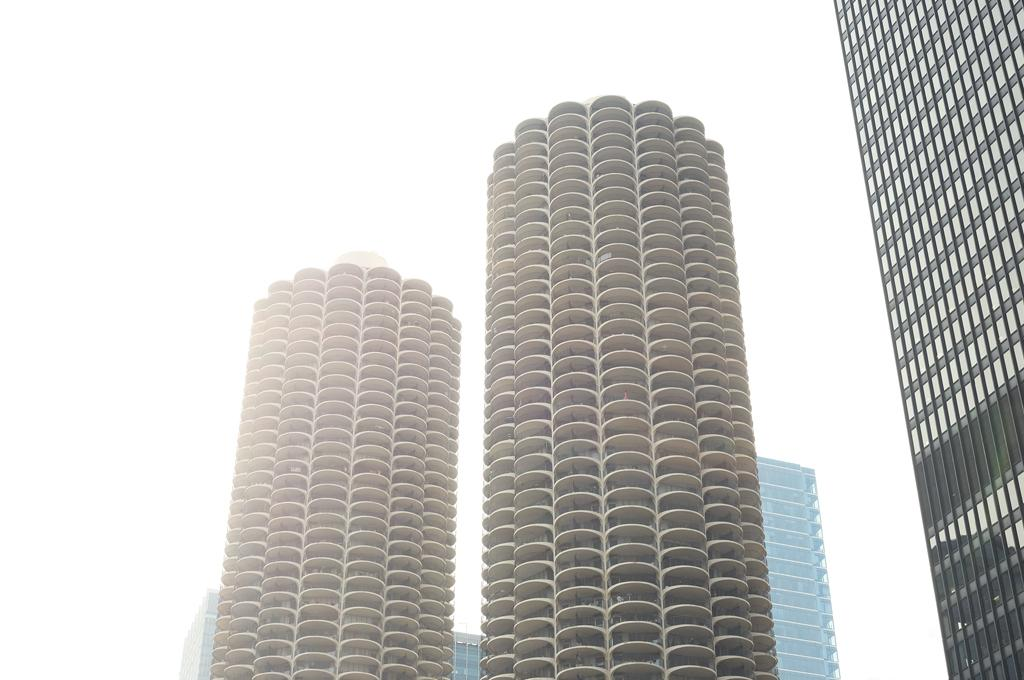Where was the image taken? The image was taken outdoors. How many buildings can be seen in the image? There are two buildings in the image. What type of buildings are present in the image? There are skyscrapers in the image. What type of insect can be seen flying around the skyscrapers in the image? There are no insects visible in the image; it only features two skyscrapers. What type of bread is being served in the image? There is no bread present in the image. 